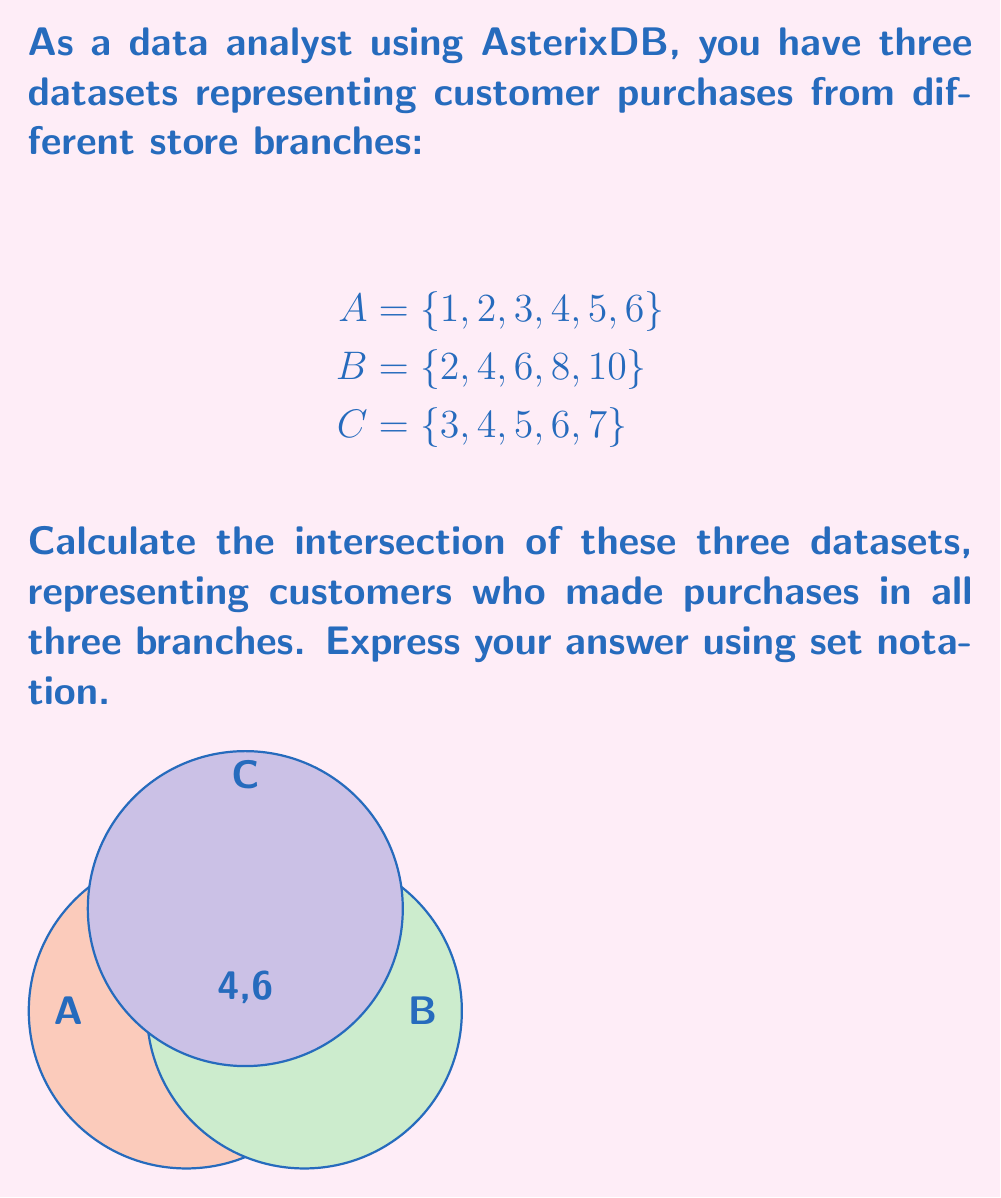Give your solution to this math problem. To find the intersection of multiple datasets in AsterixDB, we need to identify the elements that are common to all sets. Let's approach this step-by-step:

1) First, let's identify the elements present in each set:
   A: 1, 2, 3, 4, 5, 6
   B: 2, 4, 6, 8, 10
   C: 3, 4, 5, 6, 7

2) Now, we need to find elements that are present in all three sets. We can do this by checking each element:

   - 1 is only in A
   - 2 is in A and B, but not in C
   - 3 is in A and C, but not in B
   - 4 is in all three sets
   - 5 is in A and C, but not in B
   - 6 is in all three sets
   - 7 is only in C
   - 8 is only in B
   - 10 is only in B

3) From this analysis, we can see that only 4 and 6 are present in all three sets.

4) In set notation, we represent the intersection of sets using the ∩ symbol. The intersection of A, B, and C is written as A ∩ B ∩ C.

5) Therefore, we can express our answer as:

   $$A \cap B \cap C = \{4, 6\}$$

This result represents the customers who made purchases in all three store branches.
Answer: $$A \cap B \cap C = \{4, 6\}$$ 